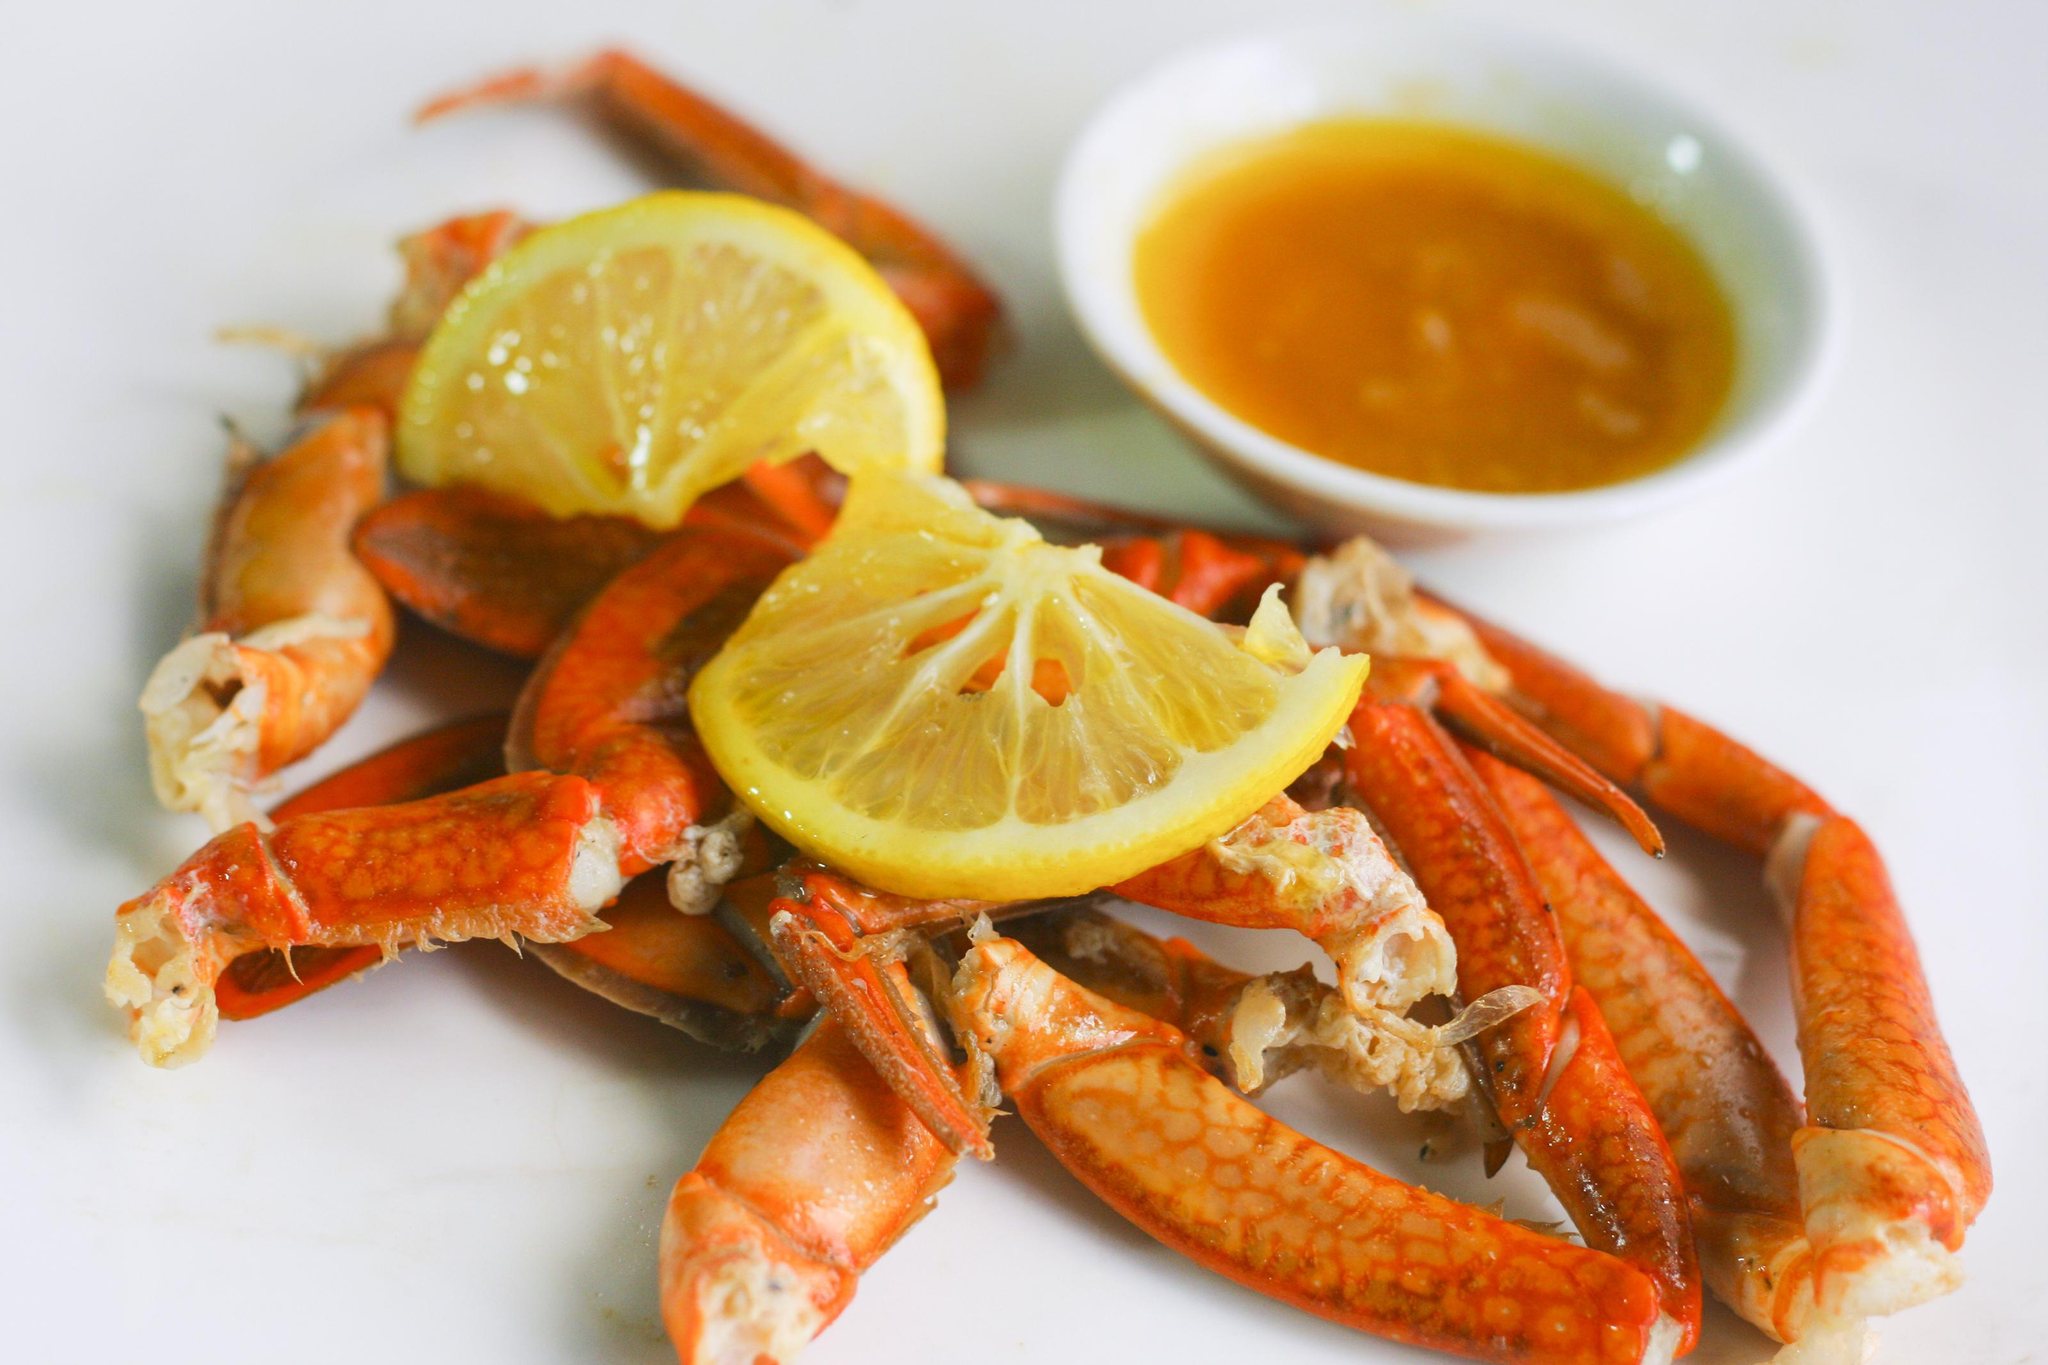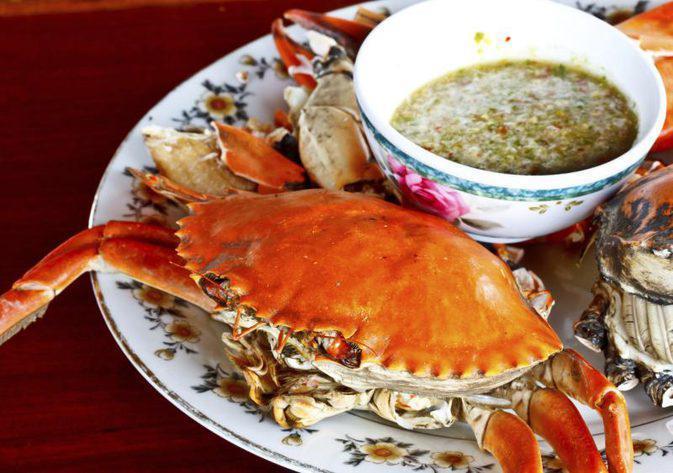The first image is the image on the left, the second image is the image on the right. Considering the images on both sides, is "IN at least one image there is a dead and full crab with it head intact sitting on a white plate." valid? Answer yes or no. Yes. The first image is the image on the left, the second image is the image on the right. Assess this claim about the two images: "The right image features a round plate containing one rightside-up crab with its red-orange shell and claws intact.". Correct or not? Answer yes or no. Yes. 